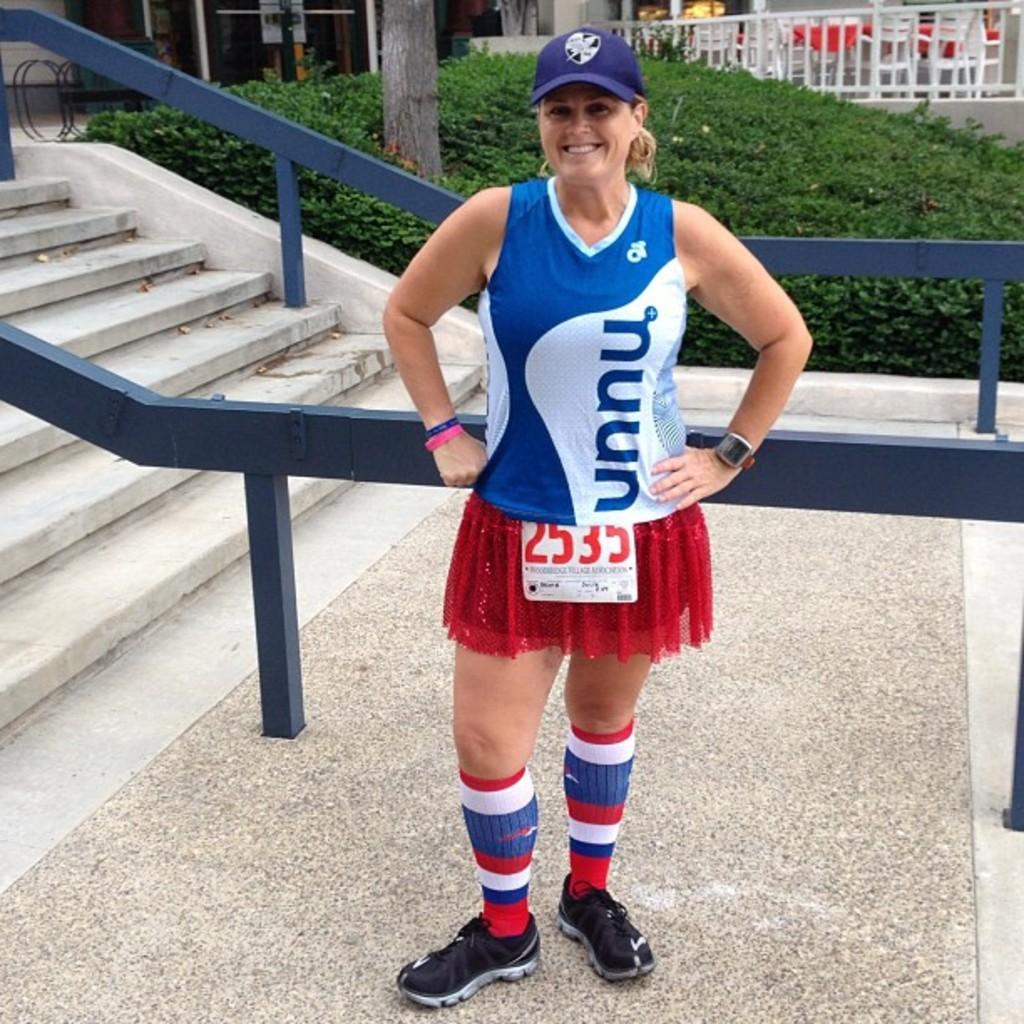Provide a one-sentence caption for the provided image. a woman wearing a UNNU jersey smiles by some stairs. 